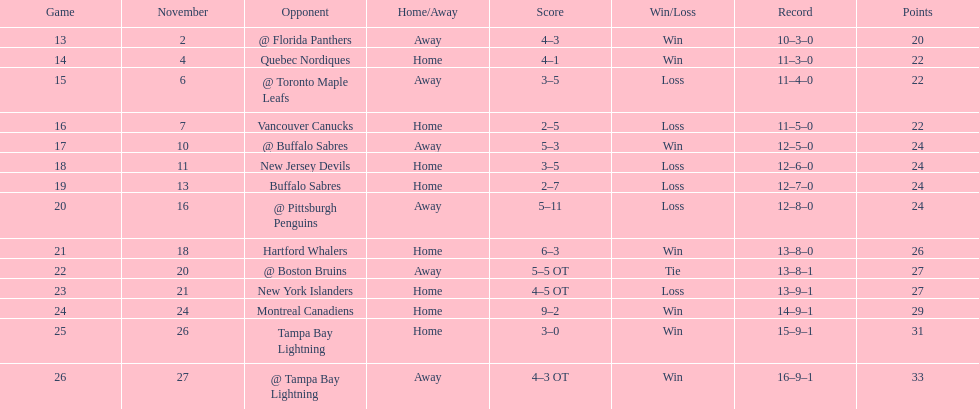Who had the most assists on the 1993-1994 flyers? Mark Recchi. Can you give me this table as a dict? {'header': ['Game', 'November', 'Opponent', 'Home/Away', 'Score', 'Win/Loss', 'Record', 'Points'], 'rows': [['13', '2', '@ Florida Panthers', 'Away', '4–3', 'Win', '10–3–0', '20'], ['14', '4', 'Quebec Nordiques', 'Home', '4–1', 'Win', '11–3–0', '22'], ['15', '6', '@ Toronto Maple Leafs', 'Away', '3–5', 'Loss', '11–4–0', '22'], ['16', '7', 'Vancouver Canucks', 'Home', '2–5', 'Loss', '11–5–0', '22'], ['17', '10', '@ Buffalo Sabres', 'Away', '5–3', 'Win', '12–5–0', '24'], ['18', '11', 'New Jersey Devils', 'Home', '3–5', 'Loss', '12–6–0', '24'], ['19', '13', 'Buffalo Sabres', 'Home', '2–7', 'Loss', '12–7–0', '24'], ['20', '16', '@ Pittsburgh Penguins', 'Away', '5–11', 'Loss', '12–8–0', '24'], ['21', '18', 'Hartford Whalers', 'Home', '6–3', 'Win', '13–8–0', '26'], ['22', '20', '@ Boston Bruins', 'Away', '5–5 OT', 'Tie', '13–8–1', '27'], ['23', '21', 'New York Islanders', 'Home', '4–5 OT', 'Loss', '13–9–1', '27'], ['24', '24', 'Montreal Canadiens', 'Home', '9–2', 'Win', '14–9–1', '29'], ['25', '26', 'Tampa Bay Lightning', 'Home', '3–0', 'Win', '15–9–1', '31'], ['26', '27', '@ Tampa Bay Lightning', 'Away', '4–3 OT', 'Win', '16–9–1', '33']]} 